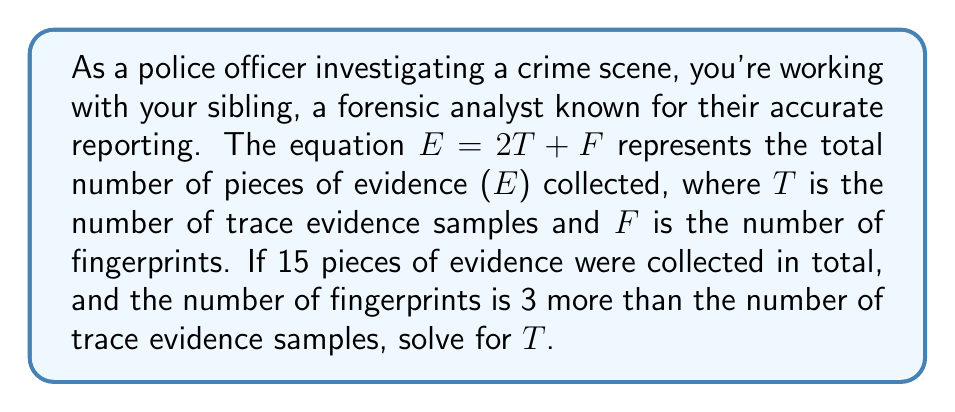Help me with this question. Let's approach this step-by-step:

1) We're given the equation: $E = 2T + F$

2) We know that the total number of pieces of evidence (E) is 15:
   $15 = 2T + F$

3) We're also told that the number of fingerprints (F) is 3 more than the number of trace evidence samples (T):
   $F = T + 3$

4) Let's substitute this into our original equation:
   $15 = 2T + (T + 3)$

5) Simplify:
   $15 = 2T + T + 3$
   $15 = 3T + 3$

6) Subtract 3 from both sides:
   $12 = 3T$

7) Divide both sides by 3:
   $4 = T$

Therefore, the number of trace evidence samples (T) is 4.

8) We can verify this by plugging it back into our original equation:
   $E = 2T + F$
   $E = 2(4) + (4 + 3)$
   $E = 8 + 7$
   $E = 15$

This confirms our solution is correct.
Answer: $T = 4$ 